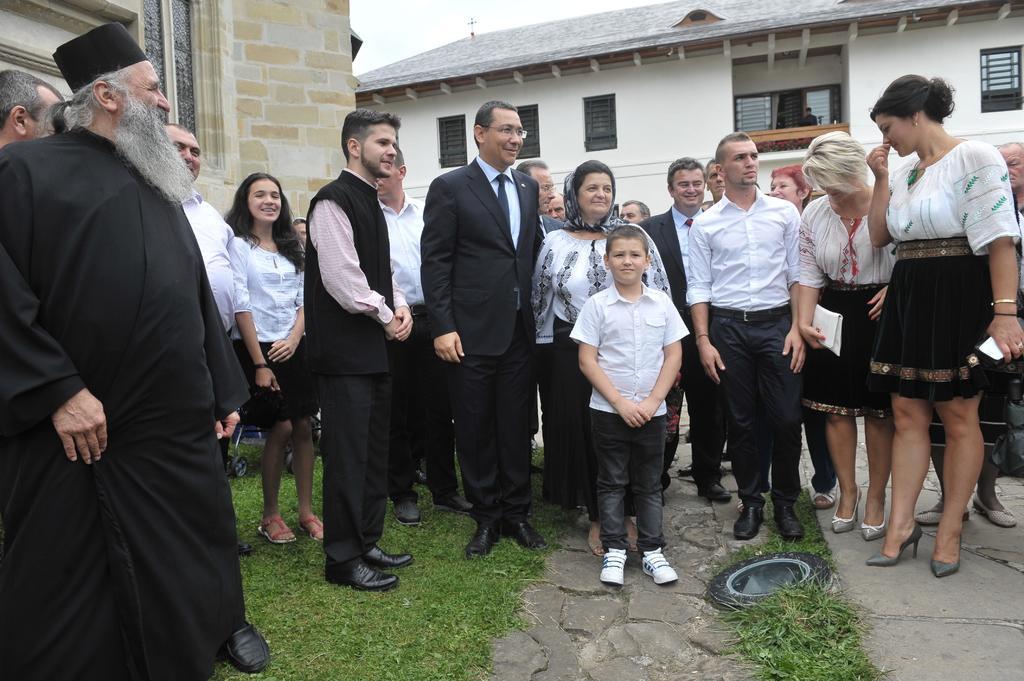Could you give a brief overview of what you see in this image? In this picture we can see a group of people on the ground, one woman is holding a mobile, another woman is holding an object, here we can see an object, grass and in the background we can see buildings, sky. 